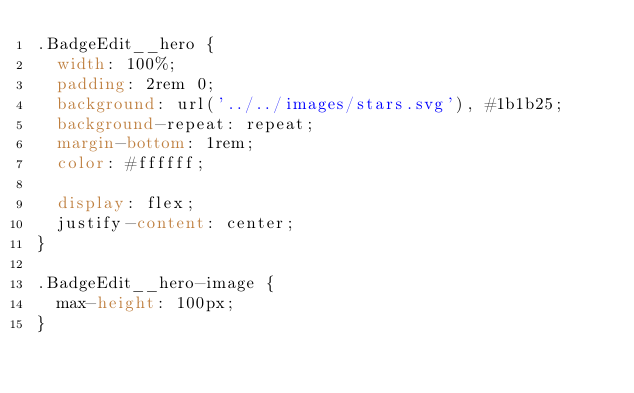<code> <loc_0><loc_0><loc_500><loc_500><_CSS_>.BadgeEdit__hero {
  width: 100%;
  padding: 2rem 0;
  background: url('../../images/stars.svg'), #1b1b25;
  background-repeat: repeat;
  margin-bottom: 1rem;
  color: #ffffff;

  display: flex;
  justify-content: center;
}

.BadgeEdit__hero-image {
  max-height: 100px;
}
</code> 